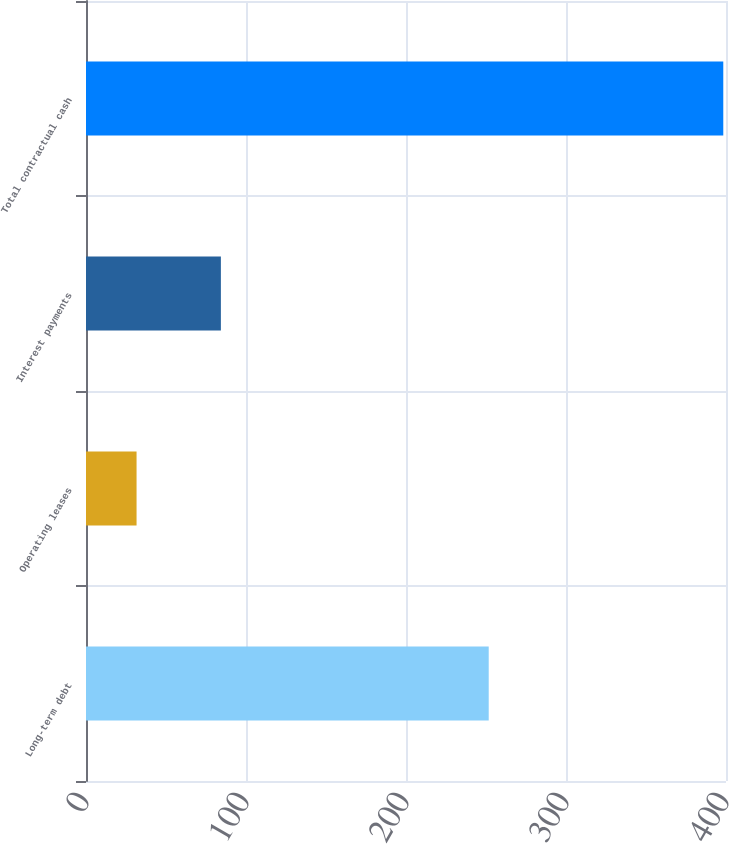Convert chart to OTSL. <chart><loc_0><loc_0><loc_500><loc_500><bar_chart><fcel>Long-term debt<fcel>Operating leases<fcel>Interest payments<fcel>Total contractual cash<nl><fcel>251.7<fcel>31.6<fcel>84.3<fcel>398.3<nl></chart> 